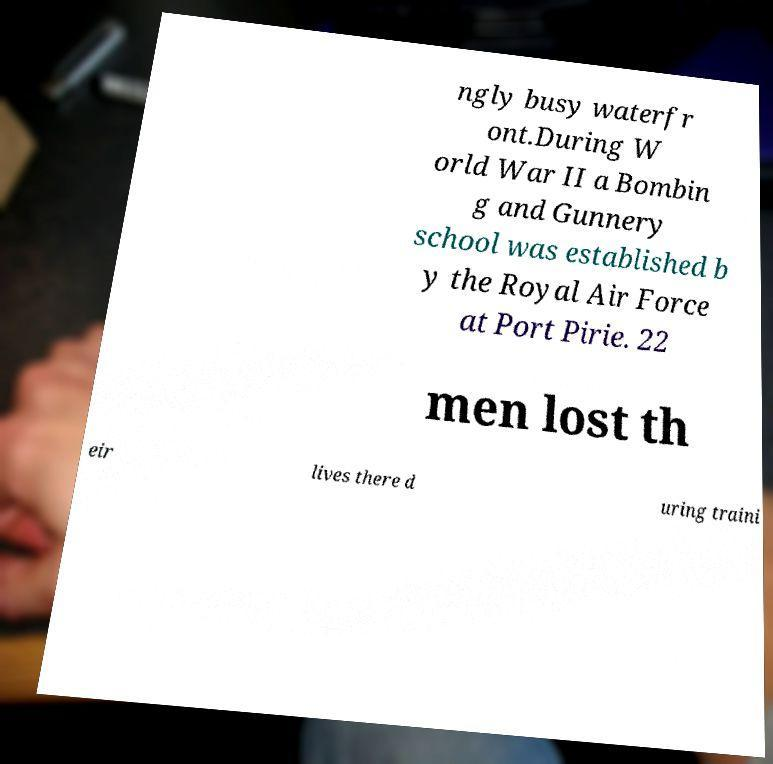I need the written content from this picture converted into text. Can you do that? ngly busy waterfr ont.During W orld War II a Bombin g and Gunnery school was established b y the Royal Air Force at Port Pirie. 22 men lost th eir lives there d uring traini 